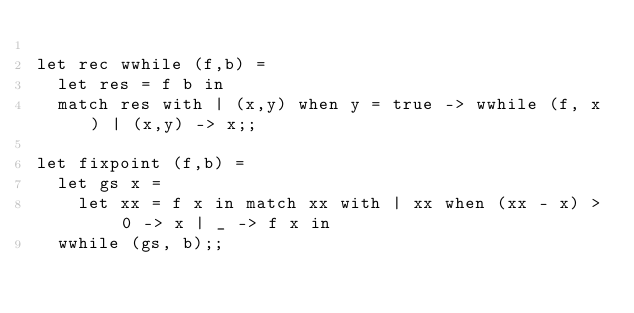Convert code to text. <code><loc_0><loc_0><loc_500><loc_500><_OCaml_>
let rec wwhile (f,b) =
  let res = f b in
  match res with | (x,y) when y = true -> wwhile (f, x) | (x,y) -> x;;

let fixpoint (f,b) =
  let gs x =
    let xx = f x in match xx with | xx when (xx - x) > 0 -> x | _ -> f x in
  wwhile (gs, b);;
</code> 